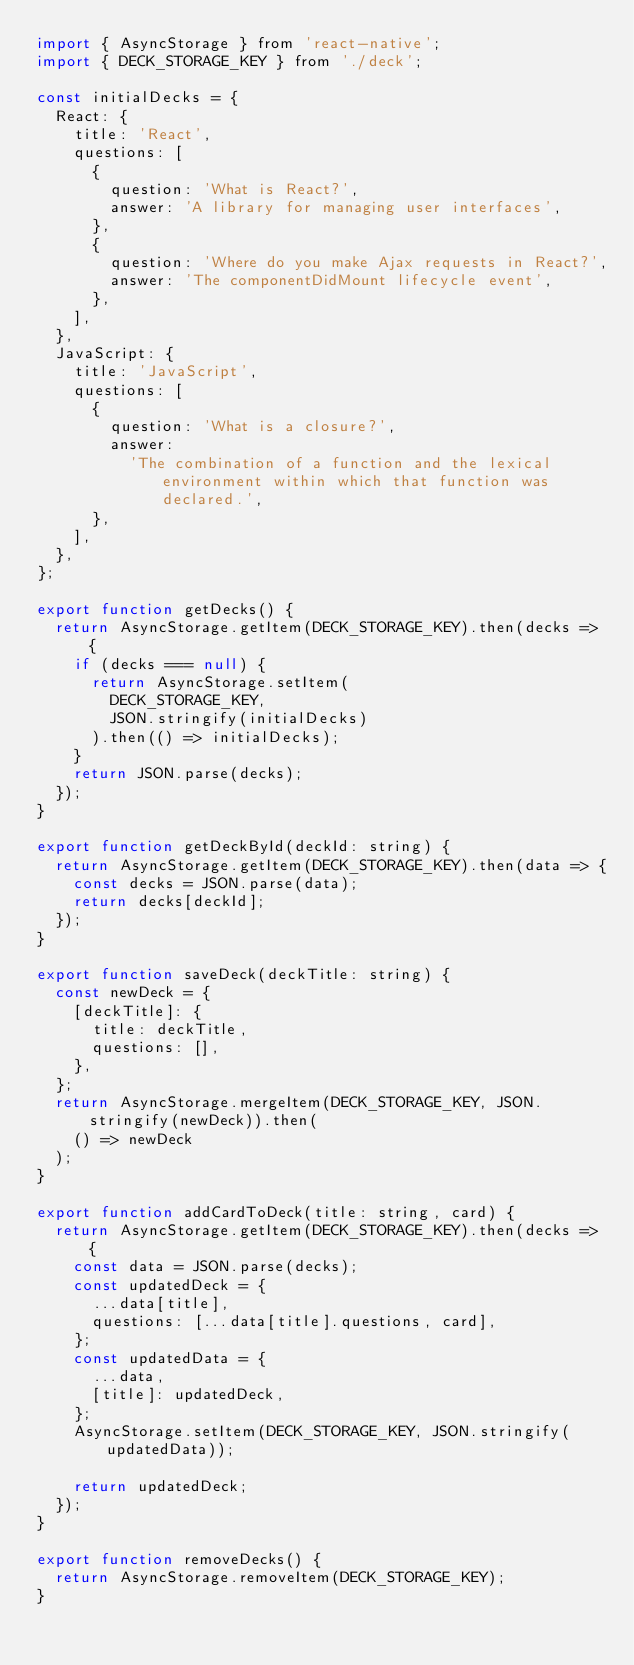<code> <loc_0><loc_0><loc_500><loc_500><_JavaScript_>import { AsyncStorage } from 'react-native';
import { DECK_STORAGE_KEY } from './deck';

const initialDecks = {
  React: {
    title: 'React',
    questions: [
      {
        question: 'What is React?',
        answer: 'A library for managing user interfaces',
      },
      {
        question: 'Where do you make Ajax requests in React?',
        answer: 'The componentDidMount lifecycle event',
      },
    ],
  },
  JavaScript: {
    title: 'JavaScript',
    questions: [
      {
        question: 'What is a closure?',
        answer:
          'The combination of a function and the lexical environment within which that function was declared.',
      },
    ],
  },
};

export function getDecks() {
  return AsyncStorage.getItem(DECK_STORAGE_KEY).then(decks => {
    if (decks === null) {
      return AsyncStorage.setItem(
        DECK_STORAGE_KEY,
        JSON.stringify(initialDecks)
      ).then(() => initialDecks);
    }
    return JSON.parse(decks);
  });
}

export function getDeckById(deckId: string) {
  return AsyncStorage.getItem(DECK_STORAGE_KEY).then(data => {
    const decks = JSON.parse(data);
    return decks[deckId];
  });
}

export function saveDeck(deckTitle: string) {
  const newDeck = {
    [deckTitle]: {
      title: deckTitle,
      questions: [],
    },
  };
  return AsyncStorage.mergeItem(DECK_STORAGE_KEY, JSON.stringify(newDeck)).then(
    () => newDeck
  );
}

export function addCardToDeck(title: string, card) {
  return AsyncStorage.getItem(DECK_STORAGE_KEY).then(decks => {
    const data = JSON.parse(decks);
    const updatedDeck = {
      ...data[title],
      questions: [...data[title].questions, card],
    };
    const updatedData = {
      ...data,
      [title]: updatedDeck,
    };
    AsyncStorage.setItem(DECK_STORAGE_KEY, JSON.stringify(updatedData));

    return updatedDeck;
  });
}

export function removeDecks() {
  return AsyncStorage.removeItem(DECK_STORAGE_KEY);
}
</code> 